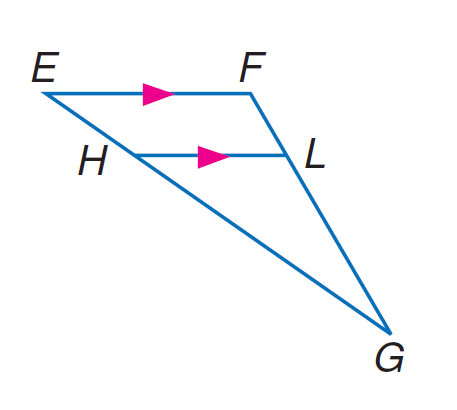Question: In \triangle E F G, H L \parallel E F, E H = 9, H G = 21, and F L = 6. Find L G.
Choices:
A. 12
B. 14
C. 15
D. 16
Answer with the letter. Answer: B 